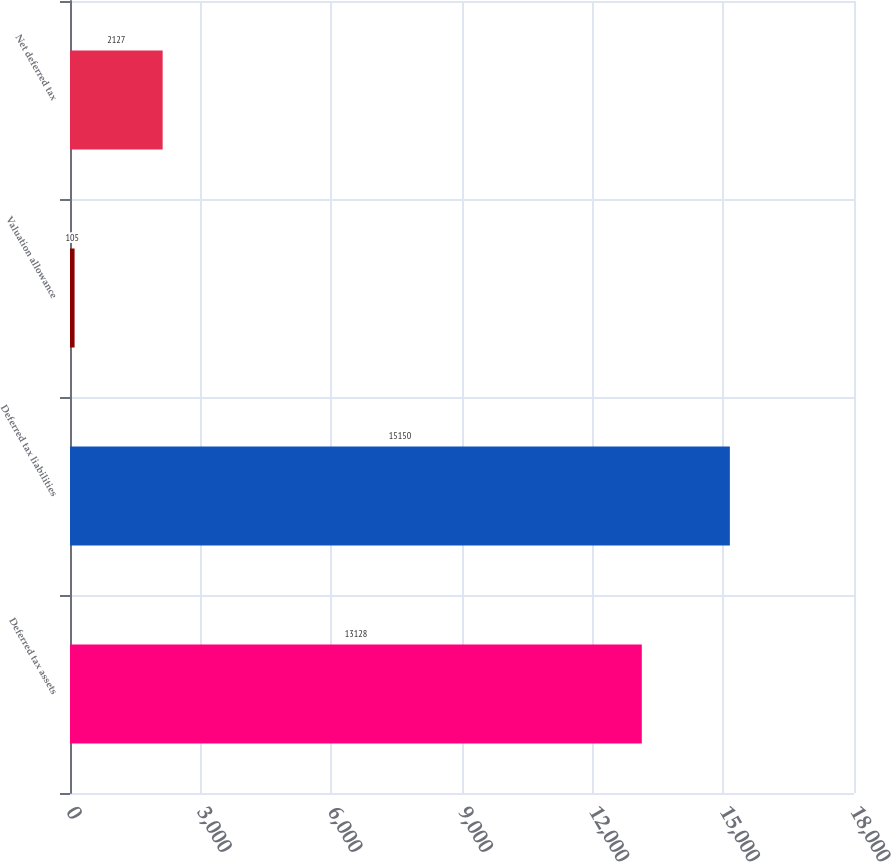<chart> <loc_0><loc_0><loc_500><loc_500><bar_chart><fcel>Deferred tax assets<fcel>Deferred tax liabilities<fcel>Valuation allowance<fcel>Net deferred tax<nl><fcel>13128<fcel>15150<fcel>105<fcel>2127<nl></chart> 